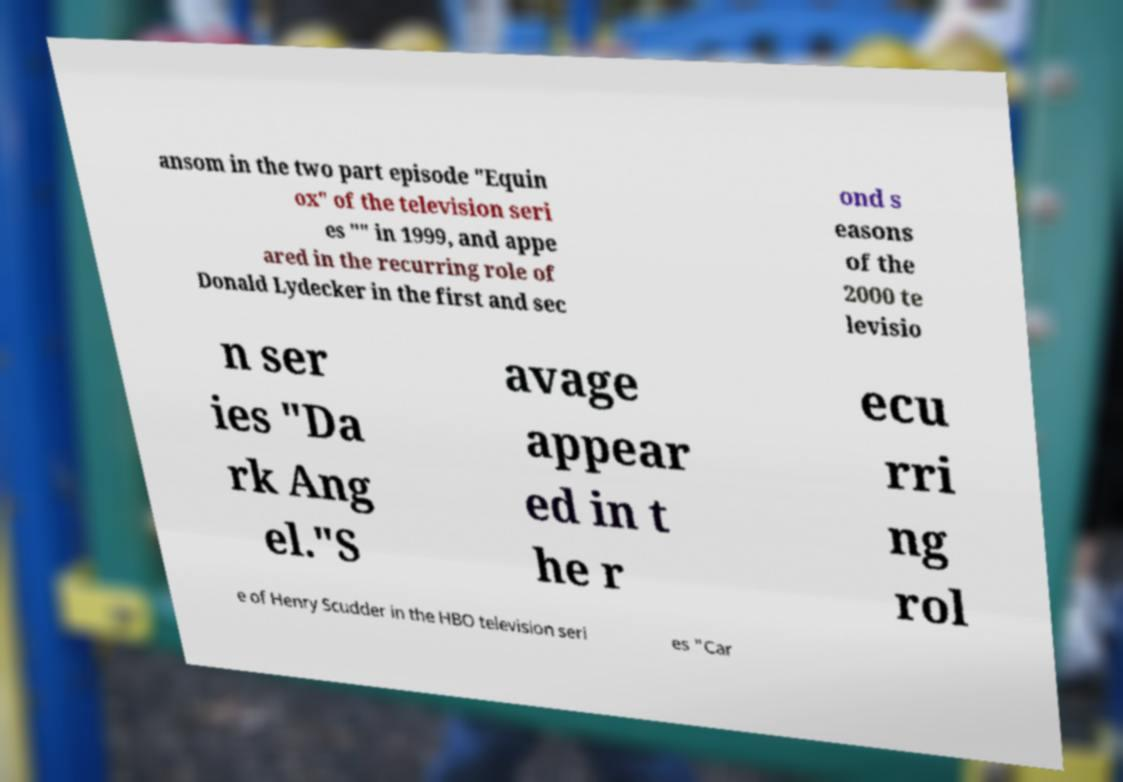Please read and relay the text visible in this image. What does it say? ansom in the two part episode "Equin ox" of the television seri es "" in 1999, and appe ared in the recurring role of Donald Lydecker in the first and sec ond s easons of the 2000 te levisio n ser ies "Da rk Ang el."S avage appear ed in t he r ecu rri ng rol e of Henry Scudder in the HBO television seri es "Car 